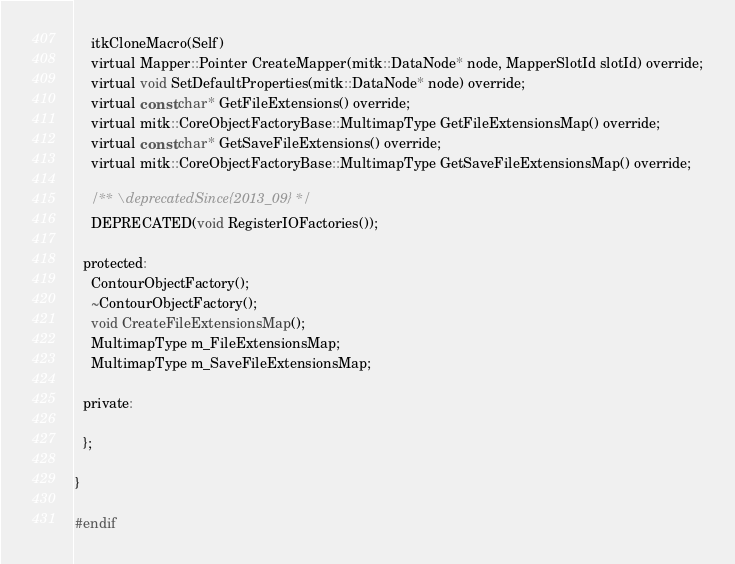Convert code to text. <code><loc_0><loc_0><loc_500><loc_500><_C_>    itkCloneMacro(Self)
    virtual Mapper::Pointer CreateMapper(mitk::DataNode* node, MapperSlotId slotId) override;
    virtual void SetDefaultProperties(mitk::DataNode* node) override;
    virtual const char* GetFileExtensions() override;
    virtual mitk::CoreObjectFactoryBase::MultimapType GetFileExtensionsMap() override;
    virtual const char* GetSaveFileExtensions() override;
    virtual mitk::CoreObjectFactoryBase::MultimapType GetSaveFileExtensionsMap() override;

    /** \deprecatedSince{2013_09} */
    DEPRECATED(void RegisterIOFactories());

  protected:
    ContourObjectFactory();
    ~ContourObjectFactory();
    void CreateFileExtensionsMap();
    MultimapType m_FileExtensionsMap;
    MultimapType m_SaveFileExtensionsMap;

  private:

  };

}

#endif
</code> 